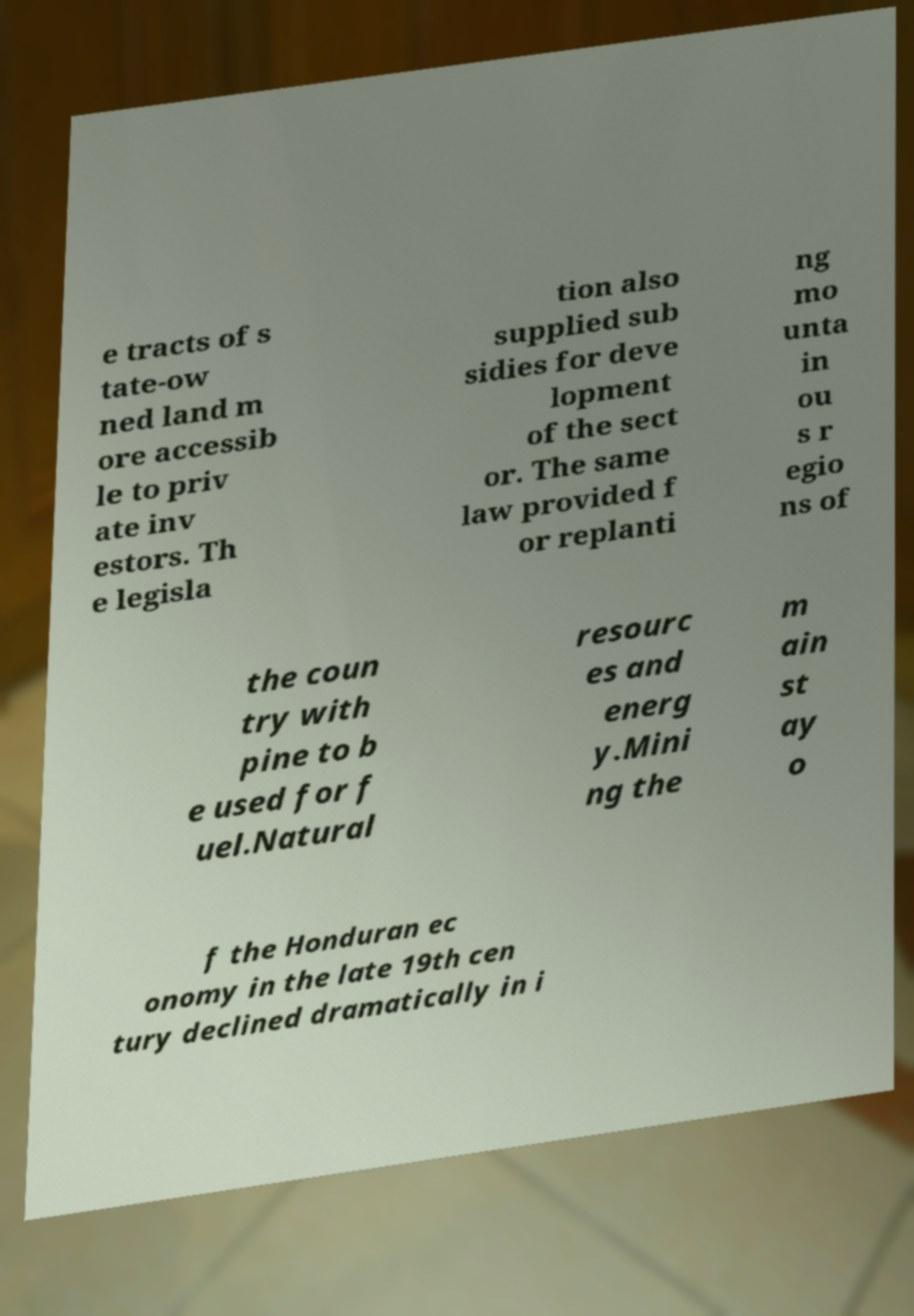Could you extract and type out the text from this image? e tracts of s tate-ow ned land m ore accessib le to priv ate inv estors. Th e legisla tion also supplied sub sidies for deve lopment of the sect or. The same law provided f or replanti ng mo unta in ou s r egio ns of the coun try with pine to b e used for f uel.Natural resourc es and energ y.Mini ng the m ain st ay o f the Honduran ec onomy in the late 19th cen tury declined dramatically in i 